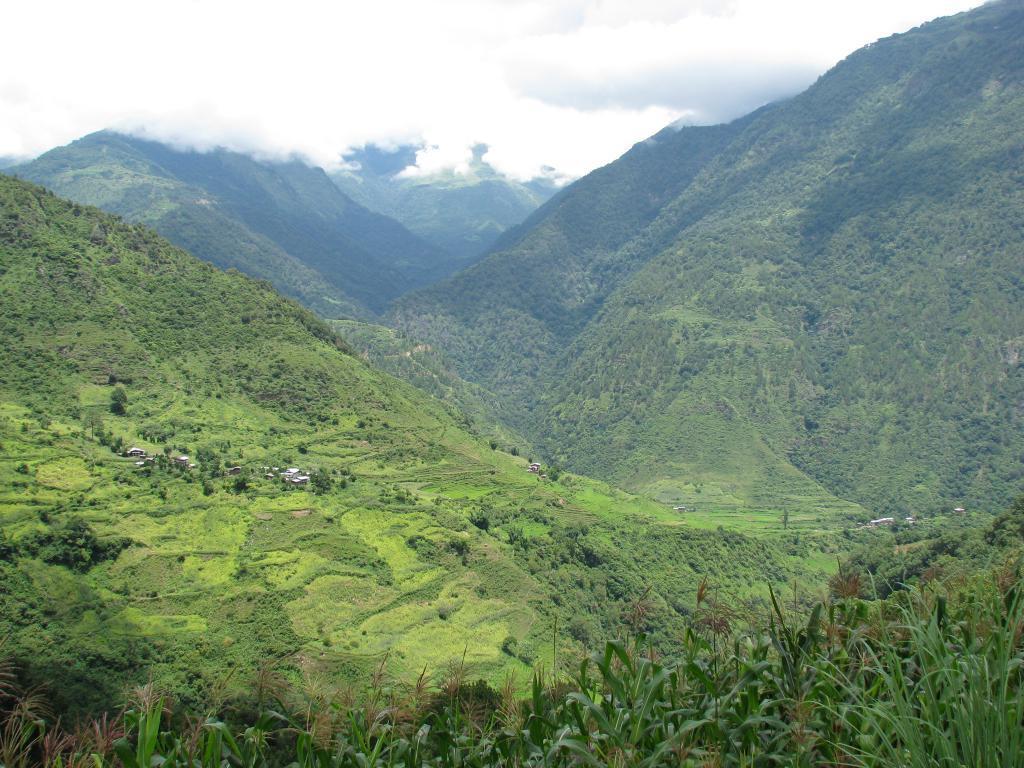Please provide a concise description of this image. In this image I can see mountains and trees. The sky is in white and blue color 